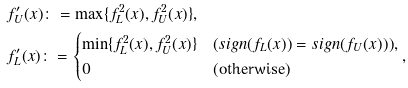<formula> <loc_0><loc_0><loc_500><loc_500>& f ^ { \prime } _ { U } ( x ) \colon = \max \{ f _ { L } ^ { 2 } ( x ) , f _ { U } ^ { 2 } ( x ) \} , \\ & f ^ { \prime } _ { L } ( x ) \colon = \begin{cases} \min \{ f _ { L } ^ { 2 } ( x ) , f _ { U } ^ { 2 } ( x ) \} & ( s i g n ( f _ { L } ( x ) ) = s i g n ( f _ { U } ( x ) ) ) , \\ 0 & ( \text {otherwise} ) \end{cases} ,</formula> 